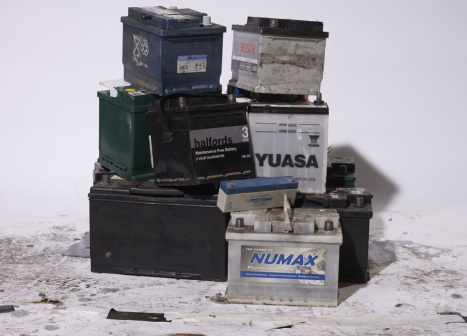Create a realistic scenario describing the collection of these batteries for recycling. The collection process usually starts when a vehicle's battery reaches the end of its lifespan. Mechanics or car owners replace these batteries and bring the old ones to designated recycling points. In this scenario, a local garage was collecting old batteries from various cars. As they fill up, a recycling company’s truck arrives and carefully loads the batteries, following all safety guidelines to prevent acid spillage or lead contamination. These batteries are then transported to a recycling facility where they are broken down, their acidic contents neutralized, and metallic parts reclaimed and purified for reuse.  What creative steps can be taken to repurpose these old batteries? Beyond recycling, old car batteries can be repurposed in innovative ways. For instance, they can be used to create solar battery banks for off-grid applications, giving them a second life in renewable energy. Artists might upcycle them into industrial-chic furniture or unique art installations. Educators could use disassembled parts for teaching students about electronics and sustainable practices, turning waste into valuable learning tools. Communities could develop battery swapping stations for DIY projects, promoting repair over replacement and fostering a culture of sustainability and creativity. 